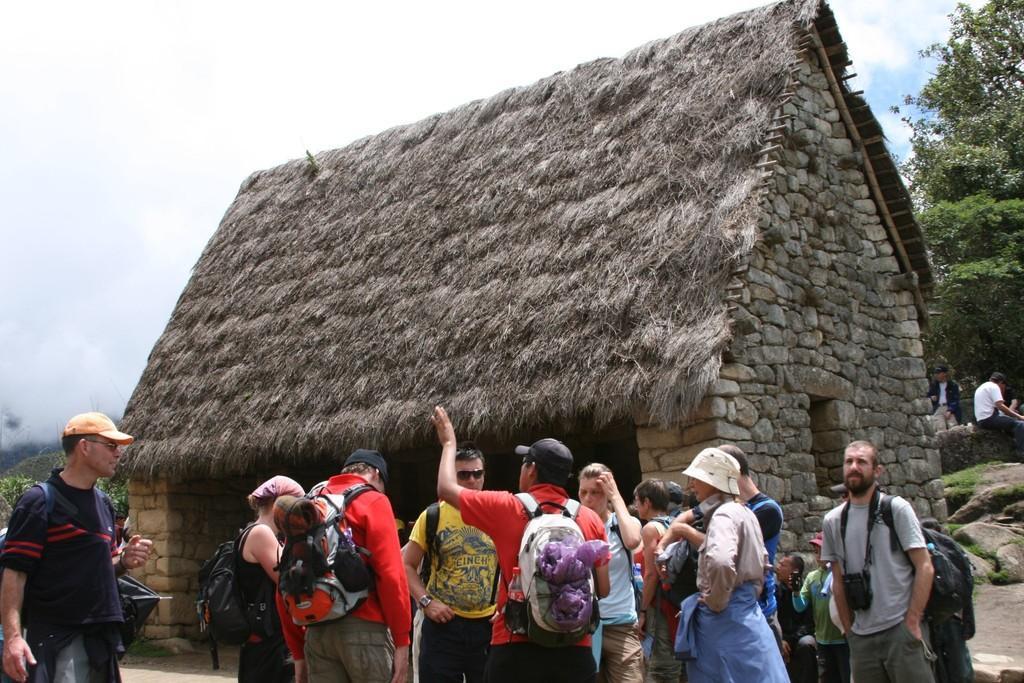In one or two sentences, can you explain what this image depicts? In the center of the image we can see a cottage. At the bottom there are people. In the background there are trees and sky. 